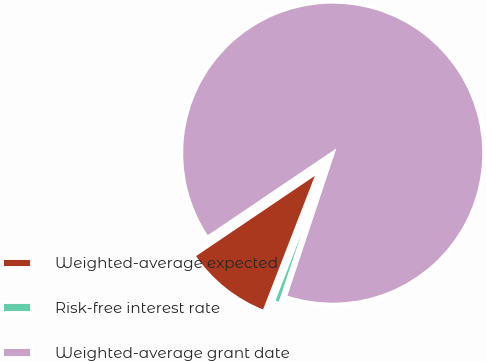Convert chart. <chart><loc_0><loc_0><loc_500><loc_500><pie_chart><fcel>Weighted-average expected<fcel>Risk-free interest rate<fcel>Weighted-average grant date<nl><fcel>9.66%<fcel>0.78%<fcel>89.56%<nl></chart> 